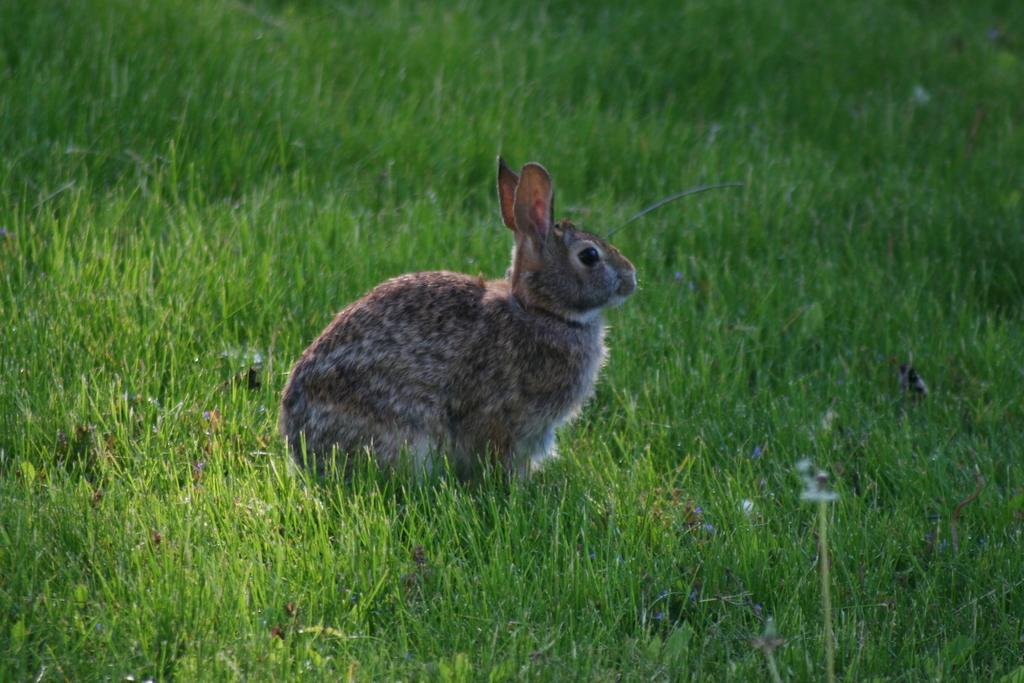What animal is present in the image? There is a rabbit in the image. In which direction is the rabbit facing? The rabbit is facing towards the right side. What type of vegetation can be seen on the ground in the image? There is grass visible on the ground in the image. Can you hear the frog crying in the image? There is no frog present in the image, and therefore no sound or crying can be heard. 